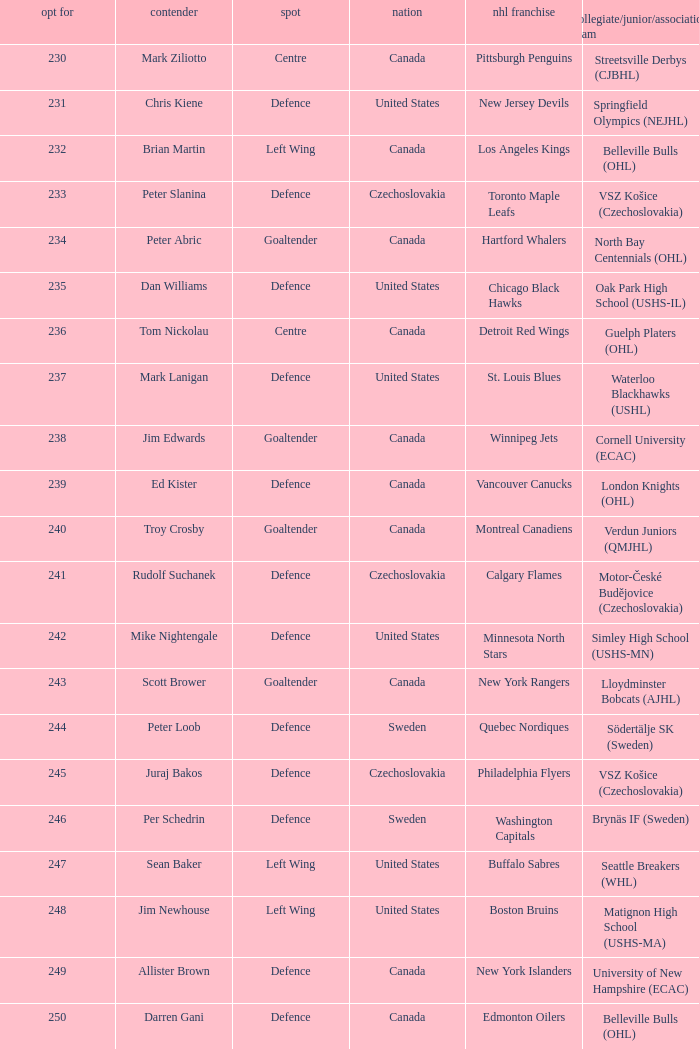What position does allister brown play. Defence. 